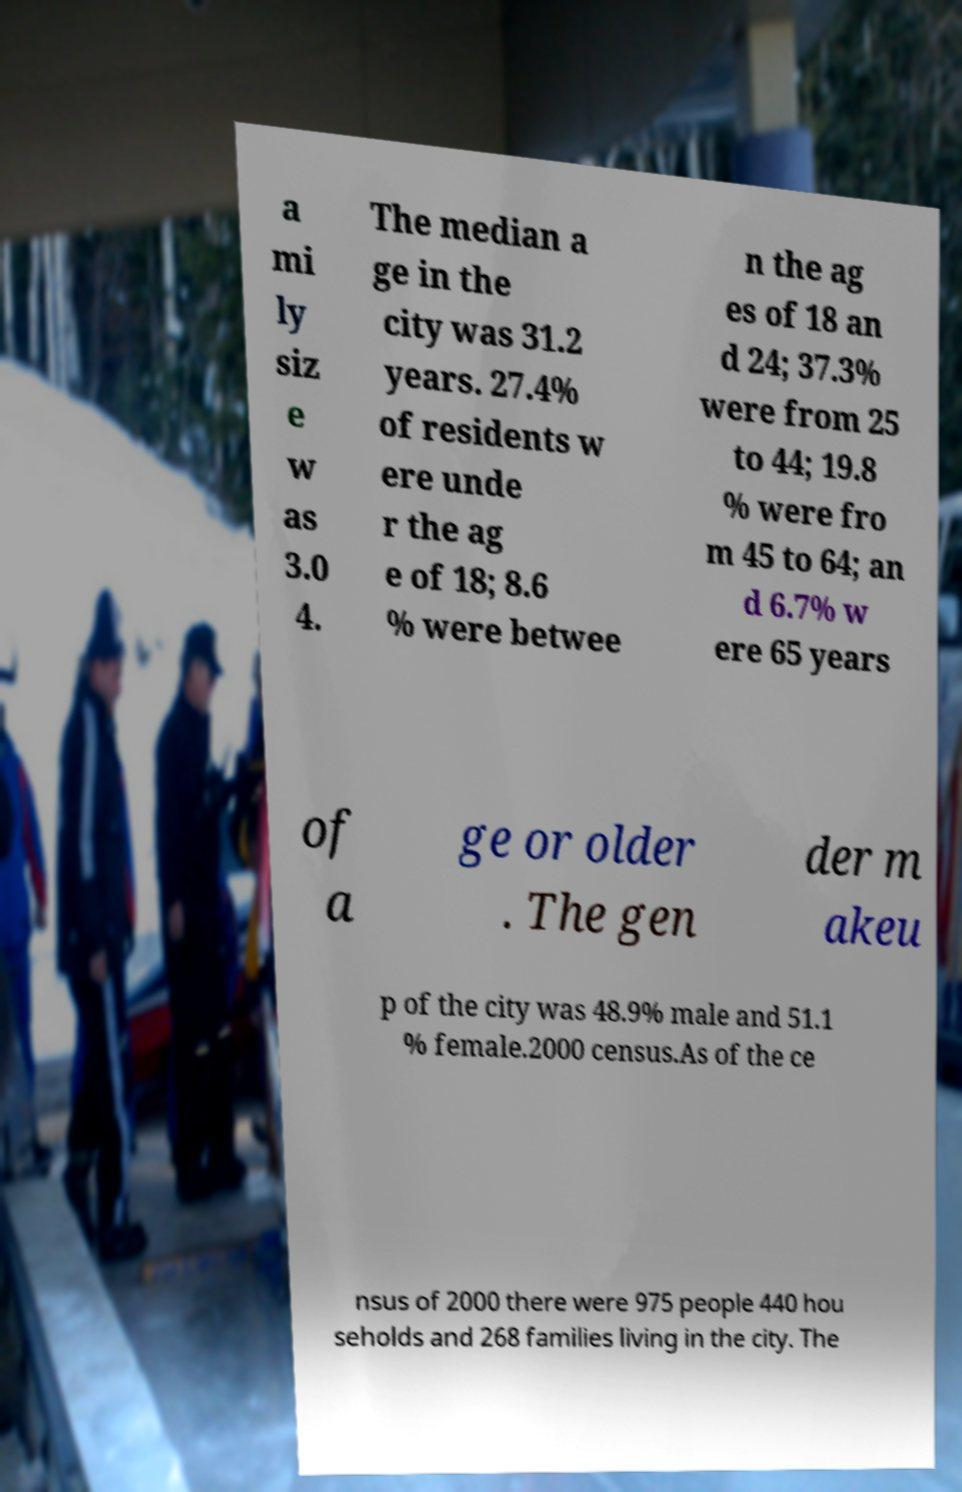Please read and relay the text visible in this image. What does it say? a mi ly siz e w as 3.0 4. The median a ge in the city was 31.2 years. 27.4% of residents w ere unde r the ag e of 18; 8.6 % were betwee n the ag es of 18 an d 24; 37.3% were from 25 to 44; 19.8 % were fro m 45 to 64; an d 6.7% w ere 65 years of a ge or older . The gen der m akeu p of the city was 48.9% male and 51.1 % female.2000 census.As of the ce nsus of 2000 there were 975 people 440 hou seholds and 268 families living in the city. The 